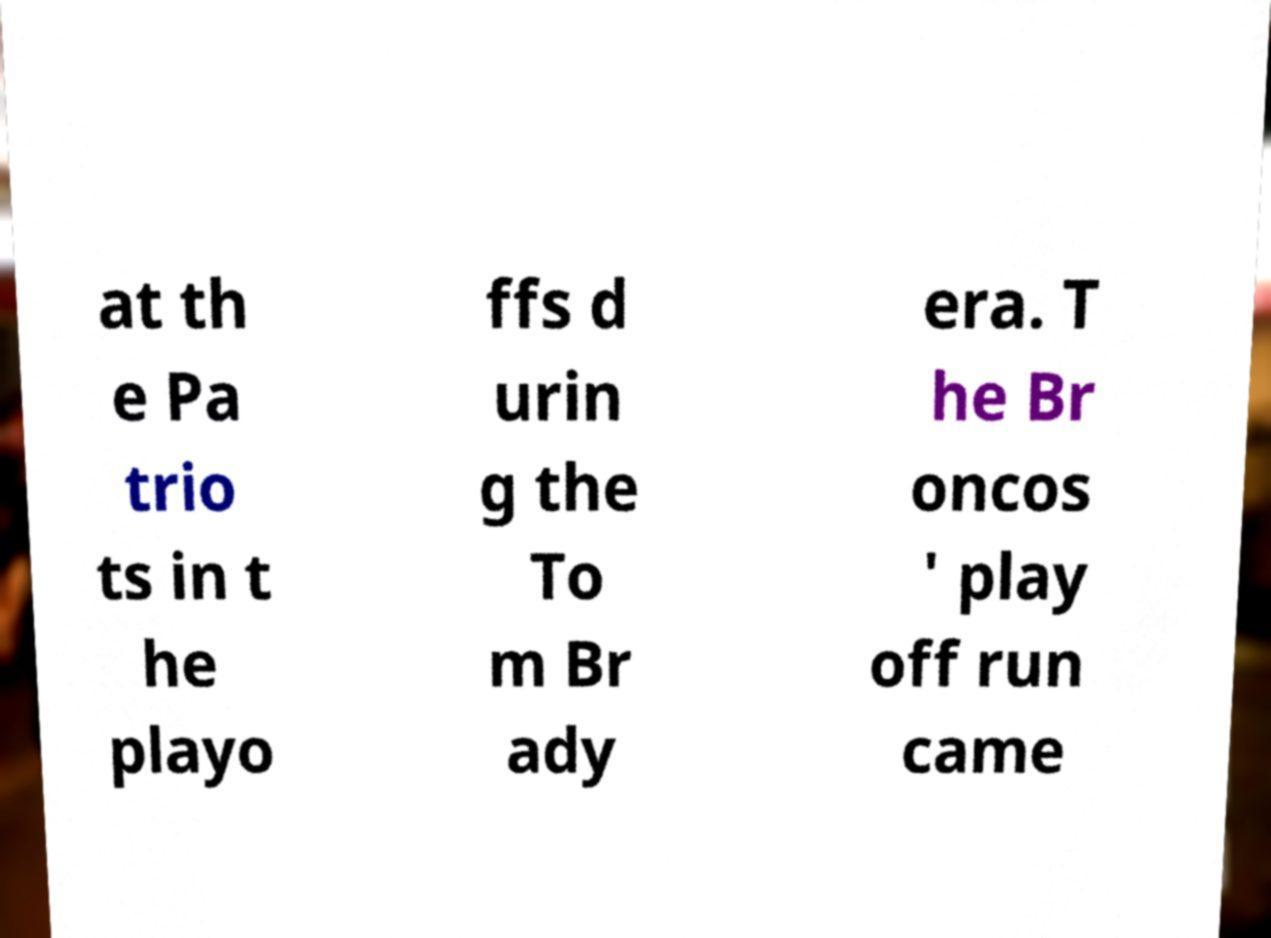Could you extract and type out the text from this image? at th e Pa trio ts in t he playo ffs d urin g the To m Br ady era. T he Br oncos ' play off run came 